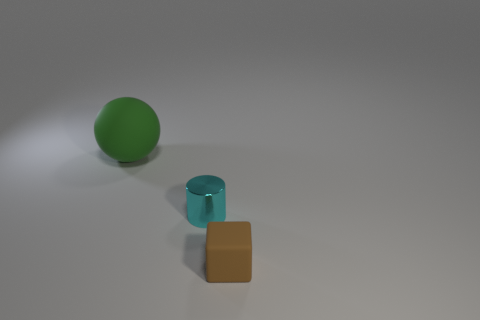Subtract all green blocks. Subtract all green cylinders. How many blocks are left? 1 Add 2 large green spheres. How many objects exist? 5 Subtract all balls. How many objects are left? 2 Subtract all tiny brown rubber blocks. Subtract all big green spheres. How many objects are left? 1 Add 1 tiny brown matte things. How many tiny brown matte things are left? 2 Add 2 tiny cyan metal cylinders. How many tiny cyan metal cylinders exist? 3 Subtract 0 red cylinders. How many objects are left? 3 